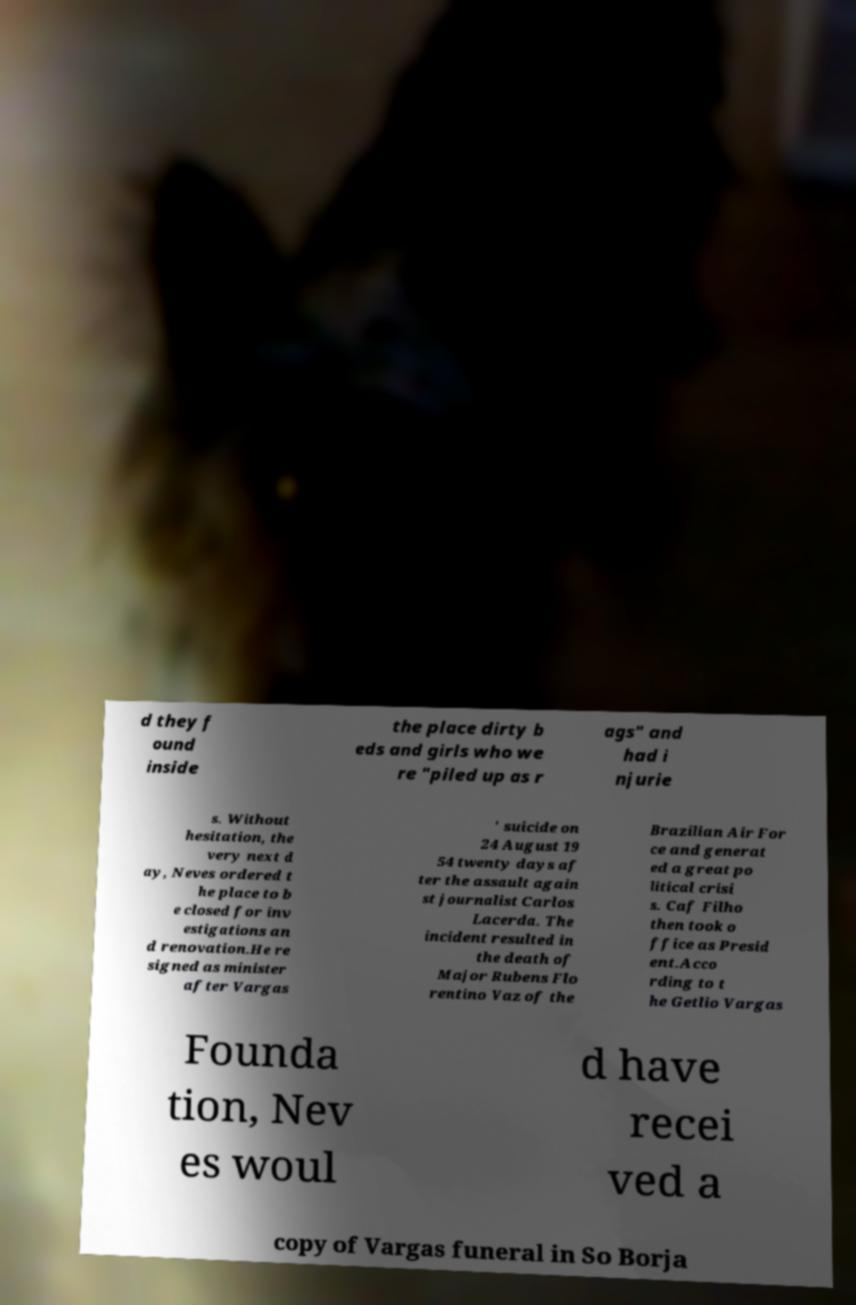Can you accurately transcribe the text from the provided image for me? d they f ound inside the place dirty b eds and girls who we re "piled up as r ags" and had i njurie s. Without hesitation, the very next d ay, Neves ordered t he place to b e closed for inv estigations an d renovation.He re signed as minister after Vargas ' suicide on 24 August 19 54 twenty days af ter the assault again st journalist Carlos Lacerda. The incident resulted in the death of Major Rubens Flo rentino Vaz of the Brazilian Air For ce and generat ed a great po litical crisi s. Caf Filho then took o ffice as Presid ent.Acco rding to t he Getlio Vargas Founda tion, Nev es woul d have recei ved a copy of Vargas funeral in So Borja 